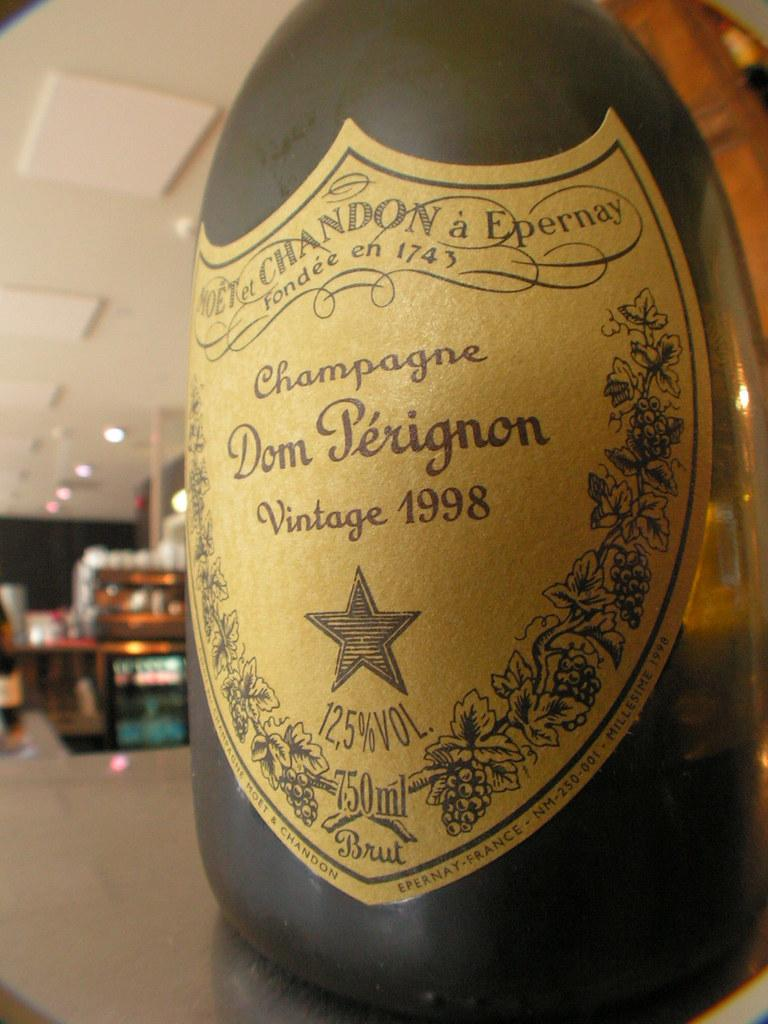What is on the table in the image? There is a champagne bottle with a label on it in the image. Where is the champagne bottle located? The champagne bottle is placed on a table. What can be seen in the background of the image? There are cupboards and the ceiling visible in the background of the image. What is on the ceiling? There are lights on the ceiling. What type of paste is being traded in the image? There is no mention of paste or trade in the image; it features a champagne bottle on a table. Can you see any bite marks on the champagne bottle? There are no bite marks visible on the champagne bottle in the image. 